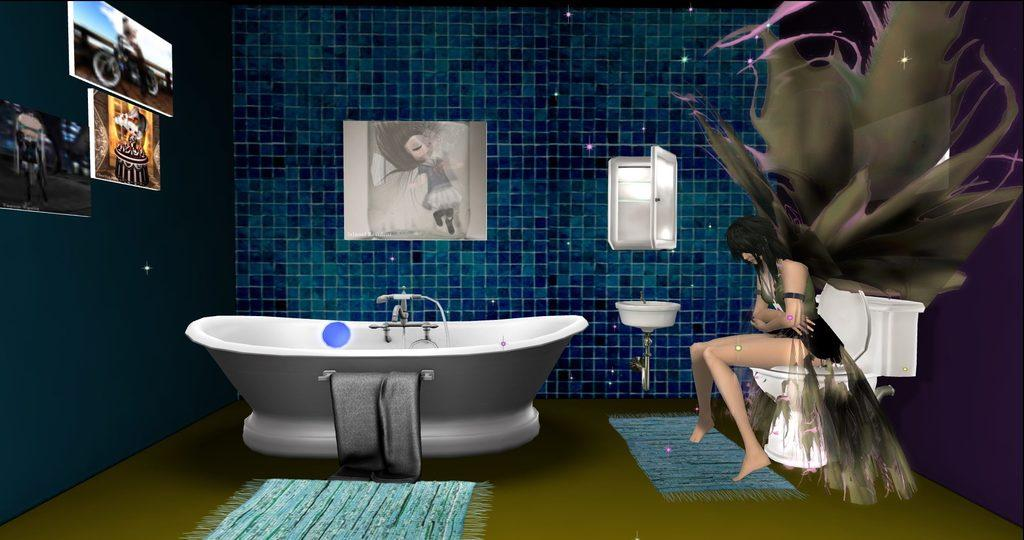What is the person in the image doing? The person is sitting on the commode in the image. What other bathroom fixtures can be seen in the image? There is a bathtub, a towel, a shower, and a wash basin in the image. What type of flooring is present in the bathroom? There is a carpet in the image. Are there any decorative elements in the bathroom? Yes, there are photo frames on a blue color wall in the image. What type of print can be seen on the pigs in the image? There are no pigs present in the image; it is a bathroom setting with a person sitting on the commode and other bathroom fixtures. 